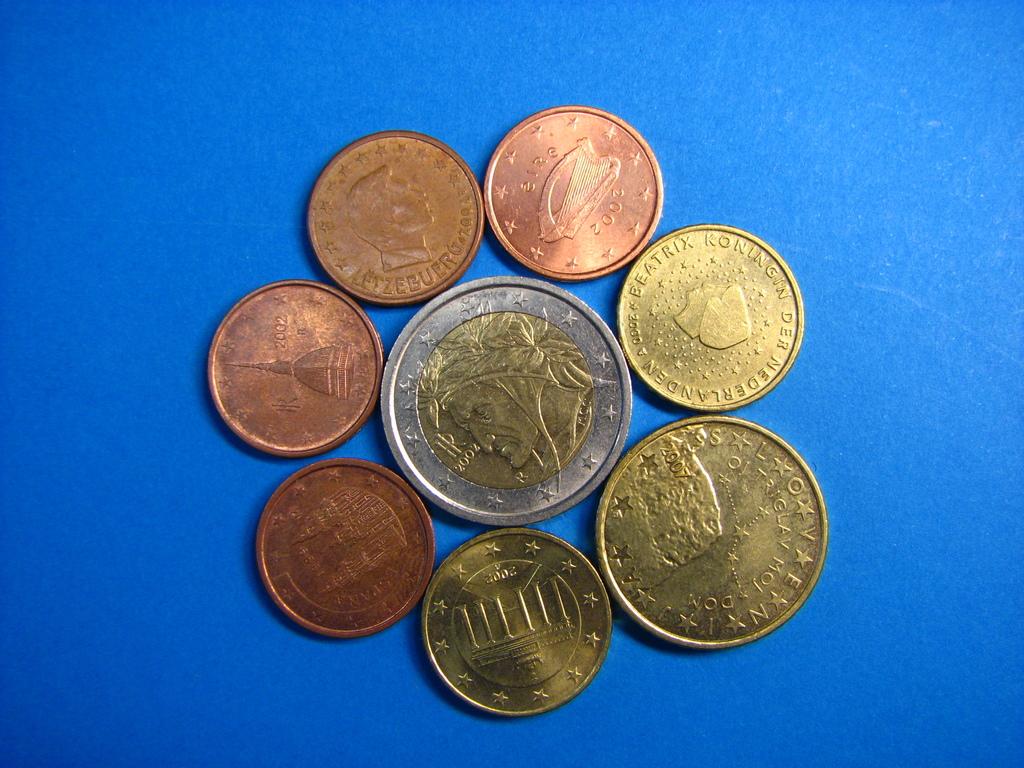Which queen is named on the middle right coin?
Provide a succinct answer. 10. Some lot of coins?
Offer a very short reply. Not a question. 